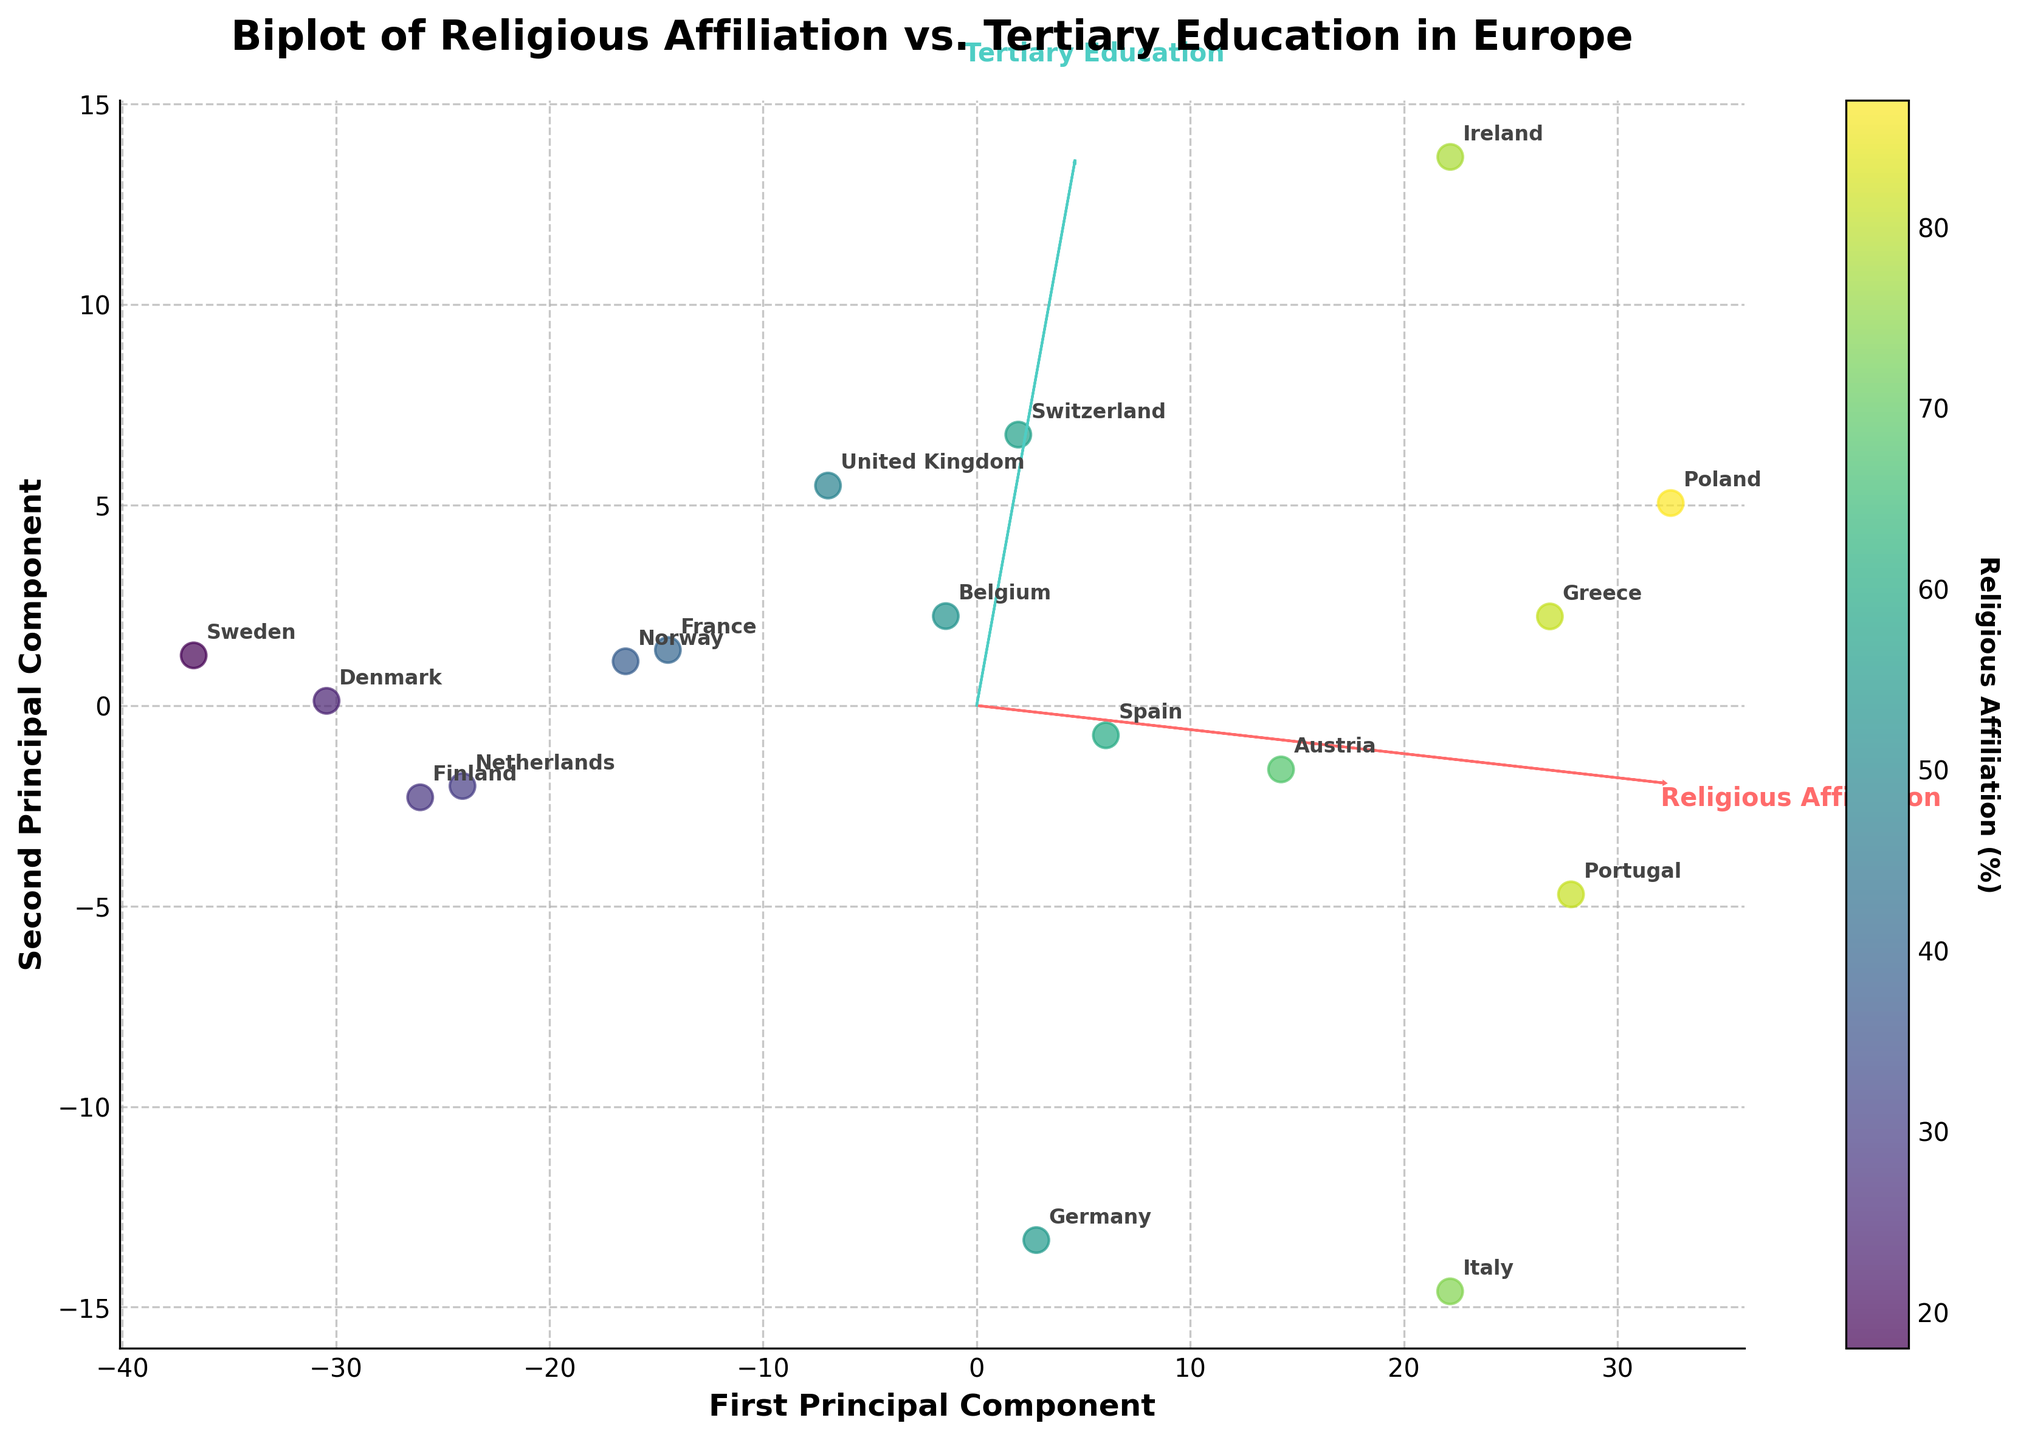Which country has the highest percentage of tertiary education attainment? To find the country with the highest percentage of tertiary education attainment, look at the data points positioned on the right top side of the vertical line in relation to the second principal component (y-axis). The United Kingdom and Ireland both have high tertiary education percentages, but Ireland has the highest at 56%.
Answer: Ireland Which feature vector has a larger length in the principal component space? The lengths of the arrows representing the feature vectors correspond to the variance those features explain. By observing the length of the two vectors, it is clear that 'Religious Affiliation' has a longer arrow, signifying it explains more variance in the data.
Answer: Religious Affiliation What is the relationship between religious affiliation and tertiary education attainment? Observing the directions of the feature vectors, they are roughly opposite. This indicates a negative correlation; countries with higher religious affiliation tend to have lower tertiary education attainment, and vice versa.
Answer: Negative correlation Which countries are almost orthogonal to the 'Religious Affiliation' vector? Countries that lie almost perpendicular to the 'Religious Affiliation' vector are those whose positions are nearly orthogonal to the direction of the arrow. United Kingdom, Sweden, and Switzerland are some examples of these countries.
Answer: United Kingdom, Sweden, Switzerland Name two countries that are similar in terms of religious affiliation and tertiary education attainment. Countries close to each other in the principal component space have similar patterns for religious affiliation and tertiary education attainment. France and Norway are placed close together on the plot.
Answer: France, Norway Which country’s educational attainment percentage is the closest to 50%? Look for countries near the position of the 50% mark on the second principal component (y-axis). Denmark has a point that lies closest to 50% educational attainment.
Answer: Denmark Compare Italy and Germany in terms of their position in religious affiliation and tertiary education attainment. Italy is positioned higher up for religious affiliation and lower for tertiary education as compared to Germany. This means Italy has higher religious affiliation and lower tertiary education attainment than Germany.
Answer: Italy has higher religious affiliation and lower tertiary education Which country lies at the extreme lower left of the plot? Countries at the lower left extreme of the biplot have very low values for both religious affiliation and tertiary education. Sweden lies towards this extreme with low percentages in both categories.
Answer: Sweden How does Poland's position indicate its level in religious affiliation and tertiary education? Poland is positioned towards the right for both the principal components but higher on the 'Religious Affiliation' vector than on the 'Tertiary Education' vector. This indicates it has a very high religious affiliation and a moderately high tertiary education attainment.
Answer: High religious affiliation, moderate tertiary education 